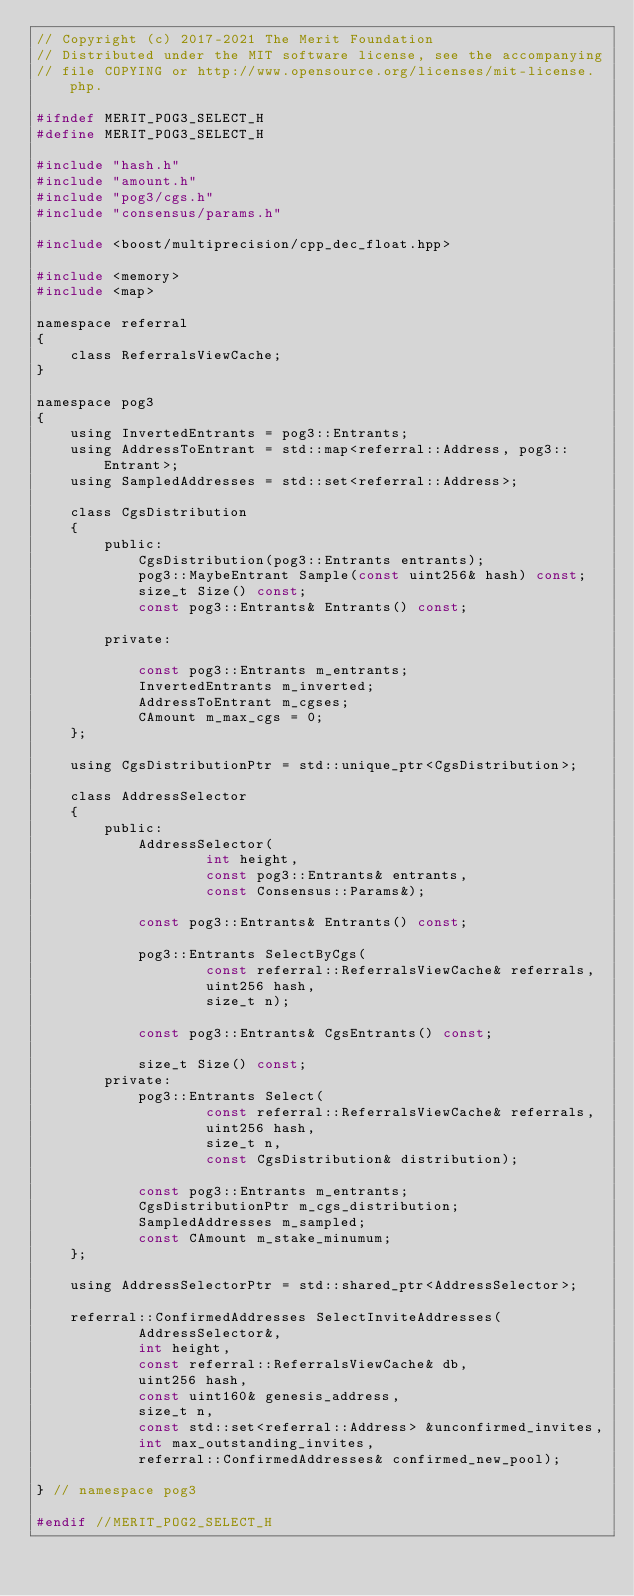<code> <loc_0><loc_0><loc_500><loc_500><_C_>// Copyright (c) 2017-2021 The Merit Foundation
// Distributed under the MIT software license, see the accompanying
// file COPYING or http://www.opensource.org/licenses/mit-license.php.

#ifndef MERIT_POG3_SELECT_H
#define MERIT_POG3_SELECT_H

#include "hash.h"
#include "amount.h"
#include "pog3/cgs.h"
#include "consensus/params.h"

#include <boost/multiprecision/cpp_dec_float.hpp>

#include <memory>
#include <map>

namespace referral
{
    class ReferralsViewCache;
}

namespace pog3
{
    using InvertedEntrants = pog3::Entrants;
    using AddressToEntrant = std::map<referral::Address, pog3::Entrant>;
    using SampledAddresses = std::set<referral::Address>;

    class CgsDistribution
    {
        public:
            CgsDistribution(pog3::Entrants entrants);
            pog3::MaybeEntrant Sample(const uint256& hash) const;
            size_t Size() const;
            const pog3::Entrants& Entrants() const;

        private:

            const pog3::Entrants m_entrants;
            InvertedEntrants m_inverted;
            AddressToEntrant m_cgses;
            CAmount m_max_cgs = 0;
    };

    using CgsDistributionPtr = std::unique_ptr<CgsDistribution>;

    class AddressSelector
    {
        public:
            AddressSelector(
                    int height,
                    const pog3::Entrants& entrants,
                    const Consensus::Params&);

            const pog3::Entrants& Entrants() const;

            pog3::Entrants SelectByCgs(
                    const referral::ReferralsViewCache& referrals,
                    uint256 hash,
                    size_t n);

            const pog3::Entrants& CgsEntrants() const;

            size_t Size() const;
        private:
            pog3::Entrants Select(
                    const referral::ReferralsViewCache& referrals,
                    uint256 hash,
                    size_t n,
                    const CgsDistribution& distribution);

            const pog3::Entrants m_entrants;
            CgsDistributionPtr m_cgs_distribution;
            SampledAddresses m_sampled;
            const CAmount m_stake_minumum;
    };

    using AddressSelectorPtr = std::shared_ptr<AddressSelector>;

    referral::ConfirmedAddresses SelectInviteAddresses(
            AddressSelector&,
            int height,
            const referral::ReferralsViewCache& db,
            uint256 hash,
            const uint160& genesis_address,
            size_t n,
            const std::set<referral::Address> &unconfirmed_invites,
            int max_outstanding_invites,
            referral::ConfirmedAddresses& confirmed_new_pool);

} // namespace pog3

#endif //MERIT_POG2_SELECT_H
</code> 